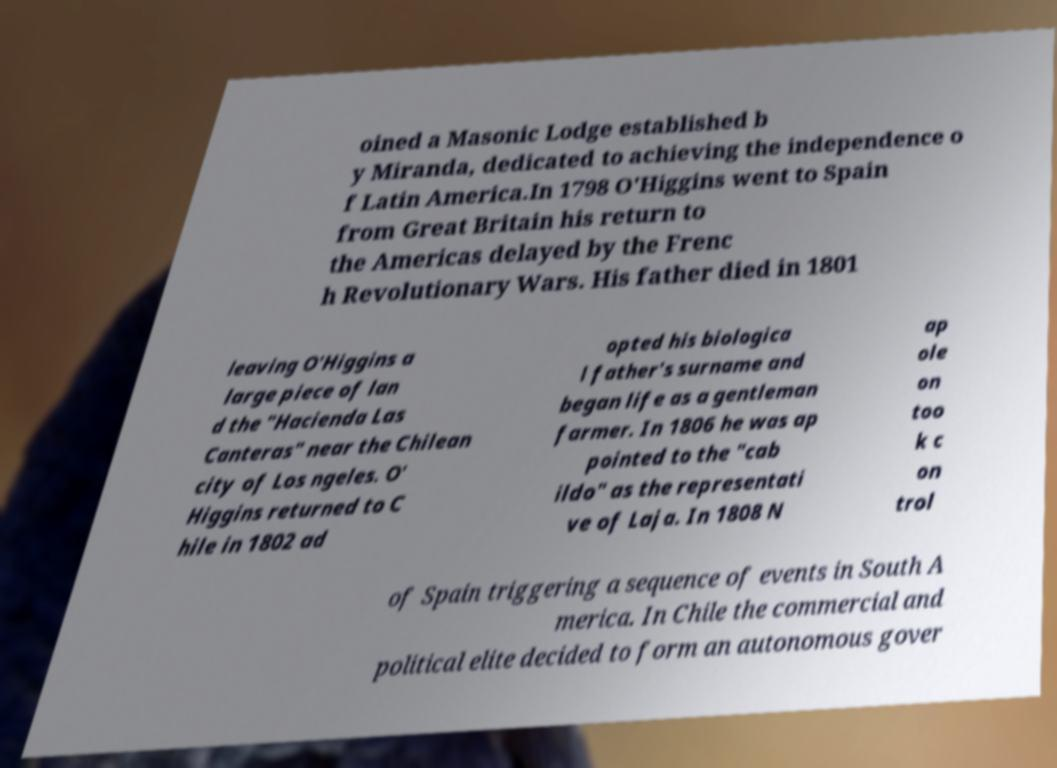Please identify and transcribe the text found in this image. oined a Masonic Lodge established b y Miranda, dedicated to achieving the independence o f Latin America.In 1798 O'Higgins went to Spain from Great Britain his return to the Americas delayed by the Frenc h Revolutionary Wars. His father died in 1801 leaving O'Higgins a large piece of lan d the "Hacienda Las Canteras" near the Chilean city of Los ngeles. O' Higgins returned to C hile in 1802 ad opted his biologica l father's surname and began life as a gentleman farmer. In 1806 he was ap pointed to the "cab ildo" as the representati ve of Laja. In 1808 N ap ole on too k c on trol of Spain triggering a sequence of events in South A merica. In Chile the commercial and political elite decided to form an autonomous gover 